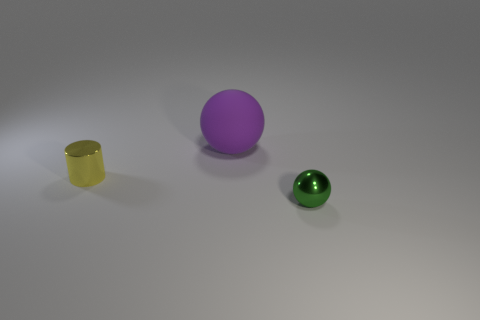Add 2 purple metal spheres. How many objects exist? 5 Subtract 1 spheres. How many spheres are left? 1 Subtract all purple balls. How many balls are left? 1 Subtract all spheres. How many objects are left? 1 Subtract 1 green spheres. How many objects are left? 2 Subtract all brown cylinders. Subtract all purple balls. How many cylinders are left? 1 Subtract all cyan cylinders. How many purple spheres are left? 1 Subtract all tiny green matte balls. Subtract all balls. How many objects are left? 1 Add 1 small things. How many small things are left? 3 Add 3 big purple rubber objects. How many big purple rubber objects exist? 4 